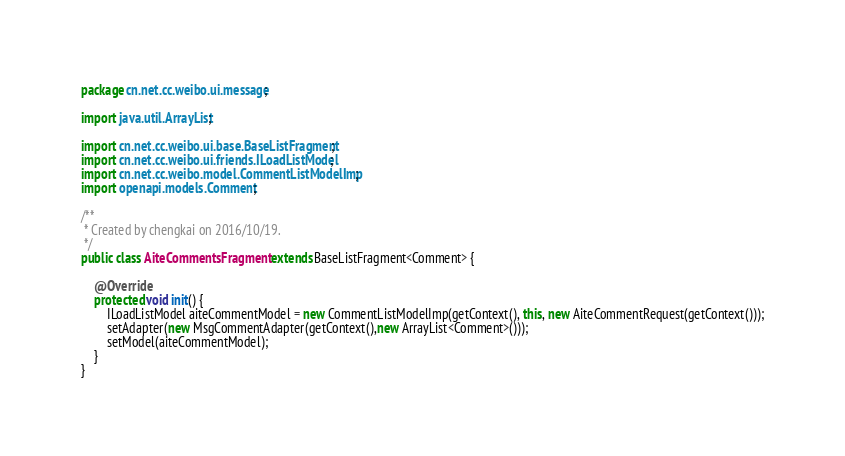Convert code to text. <code><loc_0><loc_0><loc_500><loc_500><_Java_>package cn.net.cc.weibo.ui.message;

import java.util.ArrayList;

import cn.net.cc.weibo.ui.base.BaseListFragment;
import cn.net.cc.weibo.ui.friends.ILoadListModel;
import cn.net.cc.weibo.model.CommentListModelImp;
import openapi.models.Comment;

/**
 * Created by chengkai on 2016/10/19.
 */
public class AiteCommentsFragment extends BaseListFragment<Comment> {

    @Override
    protected void init() {
        ILoadListModel aiteCommentModel = new CommentListModelImp(getContext(), this, new AiteCommentRequest(getContext()));
        setAdapter(new MsgCommentAdapter(getContext(),new ArrayList<Comment>()));
        setModel(aiteCommentModel);
    }
}
</code> 